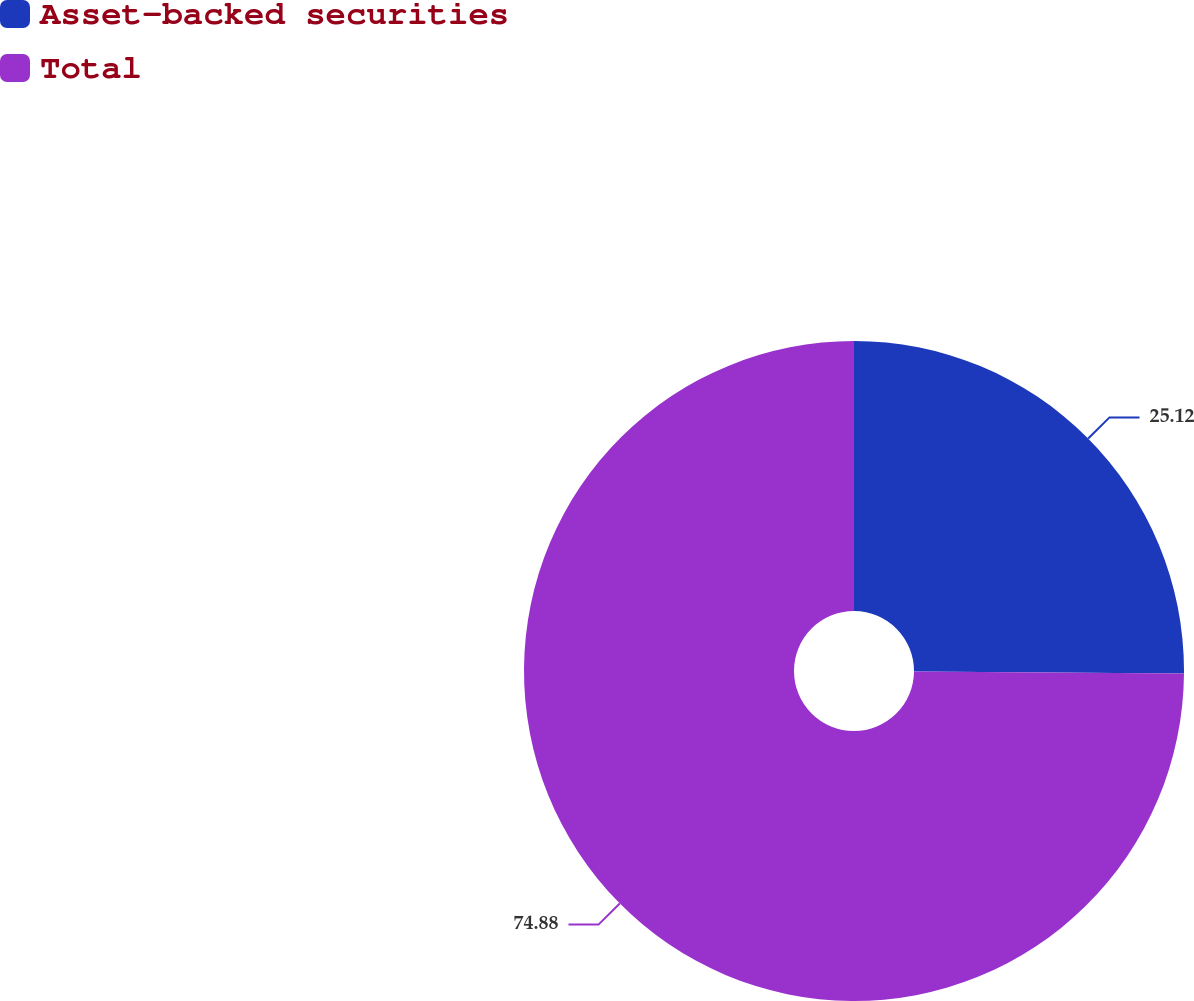<chart> <loc_0><loc_0><loc_500><loc_500><pie_chart><fcel>Asset-backed securities<fcel>Total<nl><fcel>25.12%<fcel>74.88%<nl></chart> 